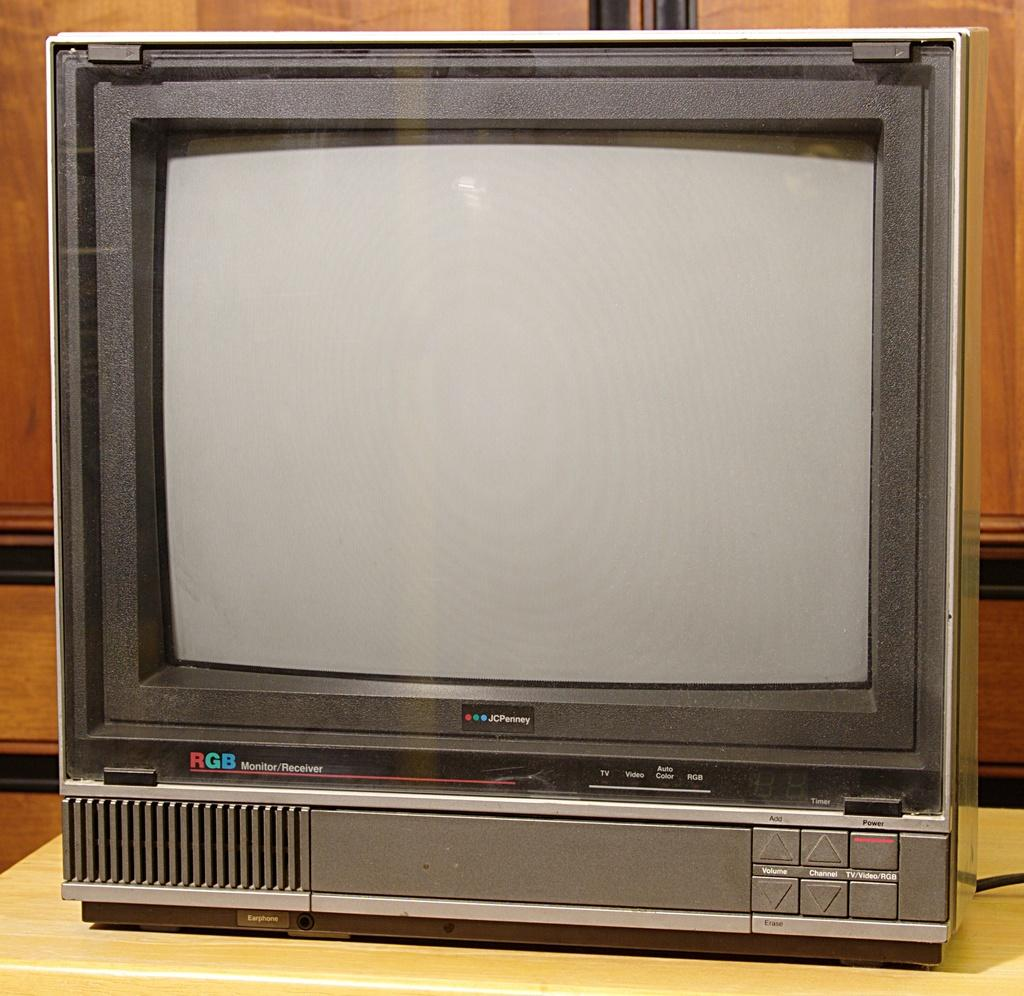<image>
Offer a succinct explanation of the picture presented. An old JcPenney RGB Monitor/Receiver sits on a table. 